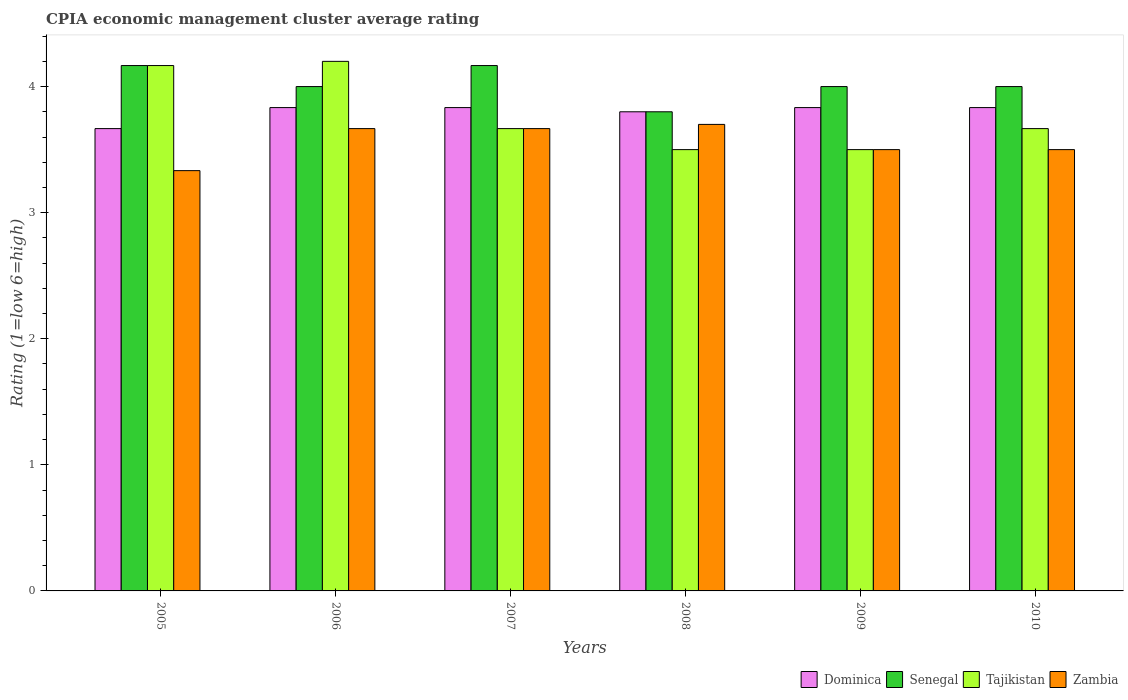How many different coloured bars are there?
Offer a very short reply. 4. Are the number of bars per tick equal to the number of legend labels?
Give a very brief answer. Yes. How many bars are there on the 6th tick from the left?
Your answer should be compact. 4. What is the label of the 1st group of bars from the left?
Give a very brief answer. 2005. What is the total CPIA rating in Dominica in the graph?
Your answer should be very brief. 22.8. What is the difference between the CPIA rating in Senegal in 2005 and that in 2009?
Provide a short and direct response. 0.17. What is the average CPIA rating in Senegal per year?
Your response must be concise. 4.02. In the year 2006, what is the difference between the CPIA rating in Zambia and CPIA rating in Dominica?
Your response must be concise. -0.17. In how many years, is the CPIA rating in Zambia greater than 4?
Offer a very short reply. 0. What is the ratio of the CPIA rating in Zambia in 2008 to that in 2010?
Provide a succinct answer. 1.06. Is the difference between the CPIA rating in Zambia in 2007 and 2009 greater than the difference between the CPIA rating in Dominica in 2007 and 2009?
Provide a short and direct response. Yes. What is the difference between the highest and the second highest CPIA rating in Zambia?
Ensure brevity in your answer.  0.03. What is the difference between the highest and the lowest CPIA rating in Dominica?
Provide a succinct answer. 0.17. Is it the case that in every year, the sum of the CPIA rating in Senegal and CPIA rating in Zambia is greater than the sum of CPIA rating in Dominica and CPIA rating in Tajikistan?
Provide a short and direct response. No. What does the 3rd bar from the left in 2008 represents?
Keep it short and to the point. Tajikistan. What does the 1st bar from the right in 2010 represents?
Give a very brief answer. Zambia. Is it the case that in every year, the sum of the CPIA rating in Zambia and CPIA rating in Tajikistan is greater than the CPIA rating in Dominica?
Ensure brevity in your answer.  Yes. Are the values on the major ticks of Y-axis written in scientific E-notation?
Ensure brevity in your answer.  No. Does the graph contain grids?
Offer a very short reply. No. Where does the legend appear in the graph?
Keep it short and to the point. Bottom right. How are the legend labels stacked?
Your answer should be very brief. Horizontal. What is the title of the graph?
Ensure brevity in your answer.  CPIA economic management cluster average rating. Does "Colombia" appear as one of the legend labels in the graph?
Give a very brief answer. No. What is the label or title of the X-axis?
Offer a terse response. Years. What is the label or title of the Y-axis?
Your answer should be compact. Rating (1=low 6=high). What is the Rating (1=low 6=high) in Dominica in 2005?
Ensure brevity in your answer.  3.67. What is the Rating (1=low 6=high) in Senegal in 2005?
Make the answer very short. 4.17. What is the Rating (1=low 6=high) of Tajikistan in 2005?
Your response must be concise. 4.17. What is the Rating (1=low 6=high) of Zambia in 2005?
Your response must be concise. 3.33. What is the Rating (1=low 6=high) in Dominica in 2006?
Your answer should be very brief. 3.83. What is the Rating (1=low 6=high) in Senegal in 2006?
Provide a succinct answer. 4. What is the Rating (1=low 6=high) of Zambia in 2006?
Give a very brief answer. 3.67. What is the Rating (1=low 6=high) of Dominica in 2007?
Your answer should be very brief. 3.83. What is the Rating (1=low 6=high) in Senegal in 2007?
Ensure brevity in your answer.  4.17. What is the Rating (1=low 6=high) in Tajikistan in 2007?
Provide a short and direct response. 3.67. What is the Rating (1=low 6=high) of Zambia in 2007?
Your response must be concise. 3.67. What is the Rating (1=low 6=high) in Dominica in 2008?
Keep it short and to the point. 3.8. What is the Rating (1=low 6=high) in Dominica in 2009?
Offer a terse response. 3.83. What is the Rating (1=low 6=high) in Tajikistan in 2009?
Make the answer very short. 3.5. What is the Rating (1=low 6=high) of Zambia in 2009?
Keep it short and to the point. 3.5. What is the Rating (1=low 6=high) in Dominica in 2010?
Offer a terse response. 3.83. What is the Rating (1=low 6=high) in Tajikistan in 2010?
Make the answer very short. 3.67. Across all years, what is the maximum Rating (1=low 6=high) in Dominica?
Offer a terse response. 3.83. Across all years, what is the maximum Rating (1=low 6=high) of Senegal?
Ensure brevity in your answer.  4.17. Across all years, what is the maximum Rating (1=low 6=high) in Zambia?
Ensure brevity in your answer.  3.7. Across all years, what is the minimum Rating (1=low 6=high) in Dominica?
Provide a succinct answer. 3.67. Across all years, what is the minimum Rating (1=low 6=high) in Senegal?
Your response must be concise. 3.8. Across all years, what is the minimum Rating (1=low 6=high) in Zambia?
Make the answer very short. 3.33. What is the total Rating (1=low 6=high) of Dominica in the graph?
Your answer should be compact. 22.8. What is the total Rating (1=low 6=high) of Senegal in the graph?
Offer a terse response. 24.13. What is the total Rating (1=low 6=high) in Tajikistan in the graph?
Keep it short and to the point. 22.7. What is the total Rating (1=low 6=high) of Zambia in the graph?
Offer a very short reply. 21.37. What is the difference between the Rating (1=low 6=high) in Senegal in 2005 and that in 2006?
Your answer should be very brief. 0.17. What is the difference between the Rating (1=low 6=high) of Tajikistan in 2005 and that in 2006?
Provide a succinct answer. -0.03. What is the difference between the Rating (1=low 6=high) in Zambia in 2005 and that in 2006?
Offer a very short reply. -0.33. What is the difference between the Rating (1=low 6=high) of Dominica in 2005 and that in 2007?
Provide a short and direct response. -0.17. What is the difference between the Rating (1=low 6=high) of Senegal in 2005 and that in 2007?
Your response must be concise. 0. What is the difference between the Rating (1=low 6=high) in Tajikistan in 2005 and that in 2007?
Make the answer very short. 0.5. What is the difference between the Rating (1=low 6=high) in Dominica in 2005 and that in 2008?
Your answer should be compact. -0.13. What is the difference between the Rating (1=low 6=high) of Senegal in 2005 and that in 2008?
Offer a terse response. 0.37. What is the difference between the Rating (1=low 6=high) in Zambia in 2005 and that in 2008?
Your response must be concise. -0.37. What is the difference between the Rating (1=low 6=high) in Dominica in 2005 and that in 2009?
Give a very brief answer. -0.17. What is the difference between the Rating (1=low 6=high) of Zambia in 2005 and that in 2009?
Ensure brevity in your answer.  -0.17. What is the difference between the Rating (1=low 6=high) in Dominica in 2006 and that in 2007?
Your response must be concise. 0. What is the difference between the Rating (1=low 6=high) in Tajikistan in 2006 and that in 2007?
Make the answer very short. 0.53. What is the difference between the Rating (1=low 6=high) of Zambia in 2006 and that in 2007?
Your response must be concise. 0. What is the difference between the Rating (1=low 6=high) of Dominica in 2006 and that in 2008?
Make the answer very short. 0.03. What is the difference between the Rating (1=low 6=high) of Senegal in 2006 and that in 2008?
Your answer should be very brief. 0.2. What is the difference between the Rating (1=low 6=high) of Tajikistan in 2006 and that in 2008?
Your response must be concise. 0.7. What is the difference between the Rating (1=low 6=high) of Zambia in 2006 and that in 2008?
Your response must be concise. -0.03. What is the difference between the Rating (1=low 6=high) of Senegal in 2006 and that in 2009?
Provide a succinct answer. 0. What is the difference between the Rating (1=low 6=high) in Tajikistan in 2006 and that in 2009?
Make the answer very short. 0.7. What is the difference between the Rating (1=low 6=high) of Zambia in 2006 and that in 2009?
Your response must be concise. 0.17. What is the difference between the Rating (1=low 6=high) in Senegal in 2006 and that in 2010?
Provide a short and direct response. 0. What is the difference between the Rating (1=low 6=high) of Tajikistan in 2006 and that in 2010?
Ensure brevity in your answer.  0.53. What is the difference between the Rating (1=low 6=high) of Senegal in 2007 and that in 2008?
Your response must be concise. 0.37. What is the difference between the Rating (1=low 6=high) of Tajikistan in 2007 and that in 2008?
Offer a terse response. 0.17. What is the difference between the Rating (1=low 6=high) of Zambia in 2007 and that in 2008?
Your response must be concise. -0.03. What is the difference between the Rating (1=low 6=high) of Senegal in 2007 and that in 2009?
Provide a short and direct response. 0.17. What is the difference between the Rating (1=low 6=high) in Zambia in 2007 and that in 2009?
Ensure brevity in your answer.  0.17. What is the difference between the Rating (1=low 6=high) of Dominica in 2007 and that in 2010?
Offer a terse response. 0. What is the difference between the Rating (1=low 6=high) in Tajikistan in 2007 and that in 2010?
Offer a terse response. 0. What is the difference between the Rating (1=low 6=high) in Zambia in 2007 and that in 2010?
Your answer should be compact. 0.17. What is the difference between the Rating (1=low 6=high) of Dominica in 2008 and that in 2009?
Offer a terse response. -0.03. What is the difference between the Rating (1=low 6=high) in Senegal in 2008 and that in 2009?
Offer a very short reply. -0.2. What is the difference between the Rating (1=low 6=high) in Zambia in 2008 and that in 2009?
Keep it short and to the point. 0.2. What is the difference between the Rating (1=low 6=high) of Dominica in 2008 and that in 2010?
Offer a terse response. -0.03. What is the difference between the Rating (1=low 6=high) in Senegal in 2008 and that in 2010?
Give a very brief answer. -0.2. What is the difference between the Rating (1=low 6=high) of Zambia in 2008 and that in 2010?
Make the answer very short. 0.2. What is the difference between the Rating (1=low 6=high) of Dominica in 2009 and that in 2010?
Keep it short and to the point. 0. What is the difference between the Rating (1=low 6=high) of Senegal in 2009 and that in 2010?
Your response must be concise. 0. What is the difference between the Rating (1=low 6=high) of Zambia in 2009 and that in 2010?
Your answer should be compact. 0. What is the difference between the Rating (1=low 6=high) of Dominica in 2005 and the Rating (1=low 6=high) of Senegal in 2006?
Ensure brevity in your answer.  -0.33. What is the difference between the Rating (1=low 6=high) in Dominica in 2005 and the Rating (1=low 6=high) in Tajikistan in 2006?
Keep it short and to the point. -0.53. What is the difference between the Rating (1=low 6=high) of Dominica in 2005 and the Rating (1=low 6=high) of Zambia in 2006?
Make the answer very short. 0. What is the difference between the Rating (1=low 6=high) in Senegal in 2005 and the Rating (1=low 6=high) in Tajikistan in 2006?
Provide a succinct answer. -0.03. What is the difference between the Rating (1=low 6=high) in Tajikistan in 2005 and the Rating (1=low 6=high) in Zambia in 2006?
Provide a short and direct response. 0.5. What is the difference between the Rating (1=low 6=high) in Dominica in 2005 and the Rating (1=low 6=high) in Tajikistan in 2007?
Provide a succinct answer. 0. What is the difference between the Rating (1=low 6=high) in Dominica in 2005 and the Rating (1=low 6=high) in Zambia in 2007?
Offer a terse response. 0. What is the difference between the Rating (1=low 6=high) in Senegal in 2005 and the Rating (1=low 6=high) in Zambia in 2007?
Give a very brief answer. 0.5. What is the difference between the Rating (1=low 6=high) in Dominica in 2005 and the Rating (1=low 6=high) in Senegal in 2008?
Provide a short and direct response. -0.13. What is the difference between the Rating (1=low 6=high) of Dominica in 2005 and the Rating (1=low 6=high) of Tajikistan in 2008?
Your answer should be very brief. 0.17. What is the difference between the Rating (1=low 6=high) in Dominica in 2005 and the Rating (1=low 6=high) in Zambia in 2008?
Your answer should be very brief. -0.03. What is the difference between the Rating (1=low 6=high) in Senegal in 2005 and the Rating (1=low 6=high) in Tajikistan in 2008?
Give a very brief answer. 0.67. What is the difference between the Rating (1=low 6=high) of Senegal in 2005 and the Rating (1=low 6=high) of Zambia in 2008?
Ensure brevity in your answer.  0.47. What is the difference between the Rating (1=low 6=high) in Tajikistan in 2005 and the Rating (1=low 6=high) in Zambia in 2008?
Keep it short and to the point. 0.47. What is the difference between the Rating (1=low 6=high) of Dominica in 2005 and the Rating (1=low 6=high) of Senegal in 2009?
Provide a succinct answer. -0.33. What is the difference between the Rating (1=low 6=high) of Dominica in 2005 and the Rating (1=low 6=high) of Tajikistan in 2009?
Ensure brevity in your answer.  0.17. What is the difference between the Rating (1=low 6=high) in Senegal in 2005 and the Rating (1=low 6=high) in Tajikistan in 2009?
Your response must be concise. 0.67. What is the difference between the Rating (1=low 6=high) in Senegal in 2005 and the Rating (1=low 6=high) in Zambia in 2009?
Make the answer very short. 0.67. What is the difference between the Rating (1=low 6=high) of Tajikistan in 2005 and the Rating (1=low 6=high) of Zambia in 2009?
Offer a very short reply. 0.67. What is the difference between the Rating (1=low 6=high) in Dominica in 2005 and the Rating (1=low 6=high) in Senegal in 2010?
Ensure brevity in your answer.  -0.33. What is the difference between the Rating (1=low 6=high) of Dominica in 2005 and the Rating (1=low 6=high) of Zambia in 2010?
Provide a short and direct response. 0.17. What is the difference between the Rating (1=low 6=high) of Senegal in 2005 and the Rating (1=low 6=high) of Tajikistan in 2010?
Offer a very short reply. 0.5. What is the difference between the Rating (1=low 6=high) in Senegal in 2005 and the Rating (1=low 6=high) in Zambia in 2010?
Your answer should be very brief. 0.67. What is the difference between the Rating (1=low 6=high) of Dominica in 2006 and the Rating (1=low 6=high) of Tajikistan in 2007?
Make the answer very short. 0.17. What is the difference between the Rating (1=low 6=high) in Dominica in 2006 and the Rating (1=low 6=high) in Zambia in 2007?
Offer a terse response. 0.17. What is the difference between the Rating (1=low 6=high) of Tajikistan in 2006 and the Rating (1=low 6=high) of Zambia in 2007?
Ensure brevity in your answer.  0.53. What is the difference between the Rating (1=low 6=high) of Dominica in 2006 and the Rating (1=low 6=high) of Tajikistan in 2008?
Ensure brevity in your answer.  0.33. What is the difference between the Rating (1=low 6=high) in Dominica in 2006 and the Rating (1=low 6=high) in Zambia in 2008?
Provide a short and direct response. 0.13. What is the difference between the Rating (1=low 6=high) in Senegal in 2006 and the Rating (1=low 6=high) in Zambia in 2008?
Make the answer very short. 0.3. What is the difference between the Rating (1=low 6=high) in Tajikistan in 2006 and the Rating (1=low 6=high) in Zambia in 2008?
Provide a short and direct response. 0.5. What is the difference between the Rating (1=low 6=high) of Dominica in 2006 and the Rating (1=low 6=high) of Senegal in 2009?
Keep it short and to the point. -0.17. What is the difference between the Rating (1=low 6=high) in Senegal in 2006 and the Rating (1=low 6=high) in Tajikistan in 2009?
Your answer should be very brief. 0.5. What is the difference between the Rating (1=low 6=high) of Senegal in 2006 and the Rating (1=low 6=high) of Zambia in 2009?
Provide a short and direct response. 0.5. What is the difference between the Rating (1=low 6=high) in Dominica in 2006 and the Rating (1=low 6=high) in Tajikistan in 2010?
Ensure brevity in your answer.  0.17. What is the difference between the Rating (1=low 6=high) of Dominica in 2006 and the Rating (1=low 6=high) of Zambia in 2010?
Keep it short and to the point. 0.33. What is the difference between the Rating (1=low 6=high) in Senegal in 2006 and the Rating (1=low 6=high) in Tajikistan in 2010?
Provide a short and direct response. 0.33. What is the difference between the Rating (1=low 6=high) of Senegal in 2006 and the Rating (1=low 6=high) of Zambia in 2010?
Make the answer very short. 0.5. What is the difference between the Rating (1=low 6=high) of Tajikistan in 2006 and the Rating (1=low 6=high) of Zambia in 2010?
Your answer should be very brief. 0.7. What is the difference between the Rating (1=low 6=high) of Dominica in 2007 and the Rating (1=low 6=high) of Zambia in 2008?
Your response must be concise. 0.13. What is the difference between the Rating (1=low 6=high) of Senegal in 2007 and the Rating (1=low 6=high) of Zambia in 2008?
Offer a terse response. 0.47. What is the difference between the Rating (1=low 6=high) of Tajikistan in 2007 and the Rating (1=low 6=high) of Zambia in 2008?
Offer a terse response. -0.03. What is the difference between the Rating (1=low 6=high) in Dominica in 2007 and the Rating (1=low 6=high) in Senegal in 2009?
Give a very brief answer. -0.17. What is the difference between the Rating (1=low 6=high) of Dominica in 2007 and the Rating (1=low 6=high) of Tajikistan in 2009?
Keep it short and to the point. 0.33. What is the difference between the Rating (1=low 6=high) of Senegal in 2007 and the Rating (1=low 6=high) of Tajikistan in 2009?
Your answer should be very brief. 0.67. What is the difference between the Rating (1=low 6=high) in Senegal in 2007 and the Rating (1=low 6=high) in Zambia in 2009?
Make the answer very short. 0.67. What is the difference between the Rating (1=low 6=high) of Tajikistan in 2007 and the Rating (1=low 6=high) of Zambia in 2009?
Give a very brief answer. 0.17. What is the difference between the Rating (1=low 6=high) of Dominica in 2007 and the Rating (1=low 6=high) of Tajikistan in 2010?
Your response must be concise. 0.17. What is the difference between the Rating (1=low 6=high) in Senegal in 2007 and the Rating (1=low 6=high) in Tajikistan in 2010?
Your answer should be compact. 0.5. What is the difference between the Rating (1=low 6=high) in Senegal in 2007 and the Rating (1=low 6=high) in Zambia in 2010?
Provide a short and direct response. 0.67. What is the difference between the Rating (1=low 6=high) of Tajikistan in 2007 and the Rating (1=low 6=high) of Zambia in 2010?
Offer a terse response. 0.17. What is the difference between the Rating (1=low 6=high) of Dominica in 2008 and the Rating (1=low 6=high) of Zambia in 2009?
Make the answer very short. 0.3. What is the difference between the Rating (1=low 6=high) of Senegal in 2008 and the Rating (1=low 6=high) of Tajikistan in 2009?
Provide a succinct answer. 0.3. What is the difference between the Rating (1=low 6=high) in Dominica in 2008 and the Rating (1=low 6=high) in Tajikistan in 2010?
Your answer should be compact. 0.13. What is the difference between the Rating (1=low 6=high) in Senegal in 2008 and the Rating (1=low 6=high) in Tajikistan in 2010?
Your answer should be very brief. 0.13. What is the difference between the Rating (1=low 6=high) of Senegal in 2008 and the Rating (1=low 6=high) of Zambia in 2010?
Make the answer very short. 0.3. What is the difference between the Rating (1=low 6=high) in Dominica in 2009 and the Rating (1=low 6=high) in Senegal in 2010?
Offer a terse response. -0.17. What is the difference between the Rating (1=low 6=high) of Tajikistan in 2009 and the Rating (1=low 6=high) of Zambia in 2010?
Keep it short and to the point. 0. What is the average Rating (1=low 6=high) of Dominica per year?
Your answer should be very brief. 3.8. What is the average Rating (1=low 6=high) in Senegal per year?
Your response must be concise. 4.02. What is the average Rating (1=low 6=high) of Tajikistan per year?
Ensure brevity in your answer.  3.78. What is the average Rating (1=low 6=high) in Zambia per year?
Your response must be concise. 3.56. In the year 2005, what is the difference between the Rating (1=low 6=high) in Dominica and Rating (1=low 6=high) in Senegal?
Keep it short and to the point. -0.5. In the year 2005, what is the difference between the Rating (1=low 6=high) in Senegal and Rating (1=low 6=high) in Tajikistan?
Ensure brevity in your answer.  0. In the year 2005, what is the difference between the Rating (1=low 6=high) in Senegal and Rating (1=low 6=high) in Zambia?
Ensure brevity in your answer.  0.83. In the year 2006, what is the difference between the Rating (1=low 6=high) of Dominica and Rating (1=low 6=high) of Tajikistan?
Offer a very short reply. -0.37. In the year 2006, what is the difference between the Rating (1=low 6=high) in Dominica and Rating (1=low 6=high) in Zambia?
Provide a succinct answer. 0.17. In the year 2006, what is the difference between the Rating (1=low 6=high) of Senegal and Rating (1=low 6=high) of Tajikistan?
Ensure brevity in your answer.  -0.2. In the year 2006, what is the difference between the Rating (1=low 6=high) in Tajikistan and Rating (1=low 6=high) in Zambia?
Your answer should be very brief. 0.53. In the year 2007, what is the difference between the Rating (1=low 6=high) in Dominica and Rating (1=low 6=high) in Senegal?
Your response must be concise. -0.33. In the year 2007, what is the difference between the Rating (1=low 6=high) in Dominica and Rating (1=low 6=high) in Tajikistan?
Keep it short and to the point. 0.17. In the year 2007, what is the difference between the Rating (1=low 6=high) of Senegal and Rating (1=low 6=high) of Tajikistan?
Offer a very short reply. 0.5. In the year 2007, what is the difference between the Rating (1=low 6=high) in Senegal and Rating (1=low 6=high) in Zambia?
Your answer should be compact. 0.5. In the year 2007, what is the difference between the Rating (1=low 6=high) in Tajikistan and Rating (1=low 6=high) in Zambia?
Your answer should be very brief. 0. In the year 2008, what is the difference between the Rating (1=low 6=high) in Dominica and Rating (1=low 6=high) in Tajikistan?
Ensure brevity in your answer.  0.3. In the year 2008, what is the difference between the Rating (1=low 6=high) of Dominica and Rating (1=low 6=high) of Zambia?
Your answer should be very brief. 0.1. In the year 2008, what is the difference between the Rating (1=low 6=high) in Senegal and Rating (1=low 6=high) in Zambia?
Offer a terse response. 0.1. In the year 2008, what is the difference between the Rating (1=low 6=high) of Tajikistan and Rating (1=low 6=high) of Zambia?
Offer a terse response. -0.2. In the year 2009, what is the difference between the Rating (1=low 6=high) of Dominica and Rating (1=low 6=high) of Senegal?
Provide a succinct answer. -0.17. In the year 2009, what is the difference between the Rating (1=low 6=high) in Senegal and Rating (1=low 6=high) in Tajikistan?
Your answer should be very brief. 0.5. In the year 2010, what is the difference between the Rating (1=low 6=high) of Dominica and Rating (1=low 6=high) of Senegal?
Ensure brevity in your answer.  -0.17. In the year 2010, what is the difference between the Rating (1=low 6=high) of Dominica and Rating (1=low 6=high) of Tajikistan?
Your answer should be compact. 0.17. What is the ratio of the Rating (1=low 6=high) in Dominica in 2005 to that in 2006?
Keep it short and to the point. 0.96. What is the ratio of the Rating (1=low 6=high) of Senegal in 2005 to that in 2006?
Your answer should be compact. 1.04. What is the ratio of the Rating (1=low 6=high) of Dominica in 2005 to that in 2007?
Provide a short and direct response. 0.96. What is the ratio of the Rating (1=low 6=high) of Senegal in 2005 to that in 2007?
Provide a succinct answer. 1. What is the ratio of the Rating (1=low 6=high) of Tajikistan in 2005 to that in 2007?
Offer a terse response. 1.14. What is the ratio of the Rating (1=low 6=high) of Zambia in 2005 to that in 2007?
Your answer should be very brief. 0.91. What is the ratio of the Rating (1=low 6=high) of Dominica in 2005 to that in 2008?
Offer a very short reply. 0.96. What is the ratio of the Rating (1=low 6=high) in Senegal in 2005 to that in 2008?
Your response must be concise. 1.1. What is the ratio of the Rating (1=low 6=high) of Tajikistan in 2005 to that in 2008?
Offer a very short reply. 1.19. What is the ratio of the Rating (1=low 6=high) of Zambia in 2005 to that in 2008?
Offer a very short reply. 0.9. What is the ratio of the Rating (1=low 6=high) in Dominica in 2005 to that in 2009?
Provide a succinct answer. 0.96. What is the ratio of the Rating (1=low 6=high) of Senegal in 2005 to that in 2009?
Make the answer very short. 1.04. What is the ratio of the Rating (1=low 6=high) in Tajikistan in 2005 to that in 2009?
Give a very brief answer. 1.19. What is the ratio of the Rating (1=low 6=high) of Zambia in 2005 to that in 2009?
Offer a terse response. 0.95. What is the ratio of the Rating (1=low 6=high) of Dominica in 2005 to that in 2010?
Make the answer very short. 0.96. What is the ratio of the Rating (1=low 6=high) of Senegal in 2005 to that in 2010?
Offer a terse response. 1.04. What is the ratio of the Rating (1=low 6=high) in Tajikistan in 2005 to that in 2010?
Provide a short and direct response. 1.14. What is the ratio of the Rating (1=low 6=high) in Dominica in 2006 to that in 2007?
Offer a terse response. 1. What is the ratio of the Rating (1=low 6=high) in Tajikistan in 2006 to that in 2007?
Provide a succinct answer. 1.15. What is the ratio of the Rating (1=low 6=high) in Zambia in 2006 to that in 2007?
Offer a terse response. 1. What is the ratio of the Rating (1=low 6=high) of Dominica in 2006 to that in 2008?
Offer a terse response. 1.01. What is the ratio of the Rating (1=low 6=high) of Senegal in 2006 to that in 2008?
Keep it short and to the point. 1.05. What is the ratio of the Rating (1=low 6=high) in Tajikistan in 2006 to that in 2008?
Your answer should be very brief. 1.2. What is the ratio of the Rating (1=low 6=high) of Dominica in 2006 to that in 2009?
Provide a short and direct response. 1. What is the ratio of the Rating (1=low 6=high) in Senegal in 2006 to that in 2009?
Offer a very short reply. 1. What is the ratio of the Rating (1=low 6=high) in Tajikistan in 2006 to that in 2009?
Your answer should be compact. 1.2. What is the ratio of the Rating (1=low 6=high) in Zambia in 2006 to that in 2009?
Make the answer very short. 1.05. What is the ratio of the Rating (1=low 6=high) of Senegal in 2006 to that in 2010?
Provide a succinct answer. 1. What is the ratio of the Rating (1=low 6=high) of Tajikistan in 2006 to that in 2010?
Your answer should be very brief. 1.15. What is the ratio of the Rating (1=low 6=high) in Zambia in 2006 to that in 2010?
Offer a very short reply. 1.05. What is the ratio of the Rating (1=low 6=high) in Dominica in 2007 to that in 2008?
Your response must be concise. 1.01. What is the ratio of the Rating (1=low 6=high) of Senegal in 2007 to that in 2008?
Provide a succinct answer. 1.1. What is the ratio of the Rating (1=low 6=high) of Tajikistan in 2007 to that in 2008?
Ensure brevity in your answer.  1.05. What is the ratio of the Rating (1=low 6=high) in Dominica in 2007 to that in 2009?
Give a very brief answer. 1. What is the ratio of the Rating (1=low 6=high) in Senegal in 2007 to that in 2009?
Provide a short and direct response. 1.04. What is the ratio of the Rating (1=low 6=high) of Tajikistan in 2007 to that in 2009?
Provide a succinct answer. 1.05. What is the ratio of the Rating (1=low 6=high) in Zambia in 2007 to that in 2009?
Give a very brief answer. 1.05. What is the ratio of the Rating (1=low 6=high) in Dominica in 2007 to that in 2010?
Your answer should be compact. 1. What is the ratio of the Rating (1=low 6=high) in Senegal in 2007 to that in 2010?
Offer a terse response. 1.04. What is the ratio of the Rating (1=low 6=high) of Zambia in 2007 to that in 2010?
Ensure brevity in your answer.  1.05. What is the ratio of the Rating (1=low 6=high) in Senegal in 2008 to that in 2009?
Keep it short and to the point. 0.95. What is the ratio of the Rating (1=low 6=high) in Zambia in 2008 to that in 2009?
Your answer should be compact. 1.06. What is the ratio of the Rating (1=low 6=high) of Dominica in 2008 to that in 2010?
Give a very brief answer. 0.99. What is the ratio of the Rating (1=low 6=high) in Senegal in 2008 to that in 2010?
Give a very brief answer. 0.95. What is the ratio of the Rating (1=low 6=high) of Tajikistan in 2008 to that in 2010?
Keep it short and to the point. 0.95. What is the ratio of the Rating (1=low 6=high) in Zambia in 2008 to that in 2010?
Ensure brevity in your answer.  1.06. What is the ratio of the Rating (1=low 6=high) of Senegal in 2009 to that in 2010?
Ensure brevity in your answer.  1. What is the ratio of the Rating (1=low 6=high) of Tajikistan in 2009 to that in 2010?
Offer a very short reply. 0.95. What is the ratio of the Rating (1=low 6=high) in Zambia in 2009 to that in 2010?
Ensure brevity in your answer.  1. What is the difference between the highest and the second highest Rating (1=low 6=high) in Dominica?
Your answer should be very brief. 0. What is the difference between the highest and the second highest Rating (1=low 6=high) of Tajikistan?
Provide a succinct answer. 0.03. What is the difference between the highest and the second highest Rating (1=low 6=high) of Zambia?
Your response must be concise. 0.03. What is the difference between the highest and the lowest Rating (1=low 6=high) in Dominica?
Offer a very short reply. 0.17. What is the difference between the highest and the lowest Rating (1=low 6=high) in Senegal?
Give a very brief answer. 0.37. What is the difference between the highest and the lowest Rating (1=low 6=high) of Zambia?
Provide a succinct answer. 0.37. 